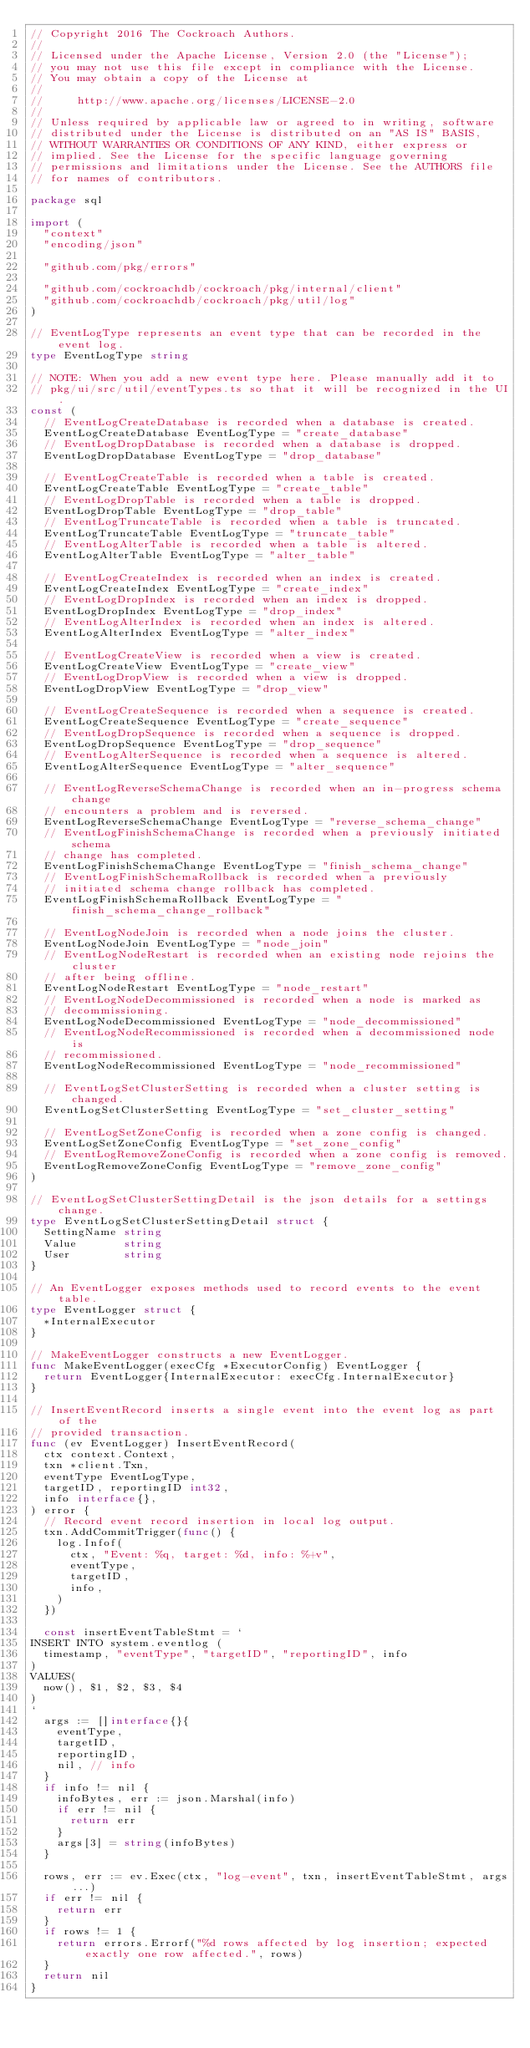Convert code to text. <code><loc_0><loc_0><loc_500><loc_500><_Go_>// Copyright 2016 The Cockroach Authors.
//
// Licensed under the Apache License, Version 2.0 (the "License");
// you may not use this file except in compliance with the License.
// You may obtain a copy of the License at
//
//     http://www.apache.org/licenses/LICENSE-2.0
//
// Unless required by applicable law or agreed to in writing, software
// distributed under the License is distributed on an "AS IS" BASIS,
// WITHOUT WARRANTIES OR CONDITIONS OF ANY KIND, either express or
// implied. See the License for the specific language governing
// permissions and limitations under the License. See the AUTHORS file
// for names of contributors.

package sql

import (
	"context"
	"encoding/json"

	"github.com/pkg/errors"

	"github.com/cockroachdb/cockroach/pkg/internal/client"
	"github.com/cockroachdb/cockroach/pkg/util/log"
)

// EventLogType represents an event type that can be recorded in the event log.
type EventLogType string

// NOTE: When you add a new event type here. Please manually add it to
// pkg/ui/src/util/eventTypes.ts so that it will be recognized in the UI.
const (
	// EventLogCreateDatabase is recorded when a database is created.
	EventLogCreateDatabase EventLogType = "create_database"
	// EventLogDropDatabase is recorded when a database is dropped.
	EventLogDropDatabase EventLogType = "drop_database"

	// EventLogCreateTable is recorded when a table is created.
	EventLogCreateTable EventLogType = "create_table"
	// EventLogDropTable is recorded when a table is dropped.
	EventLogDropTable EventLogType = "drop_table"
	// EventLogTruncateTable is recorded when a table is truncated.
	EventLogTruncateTable EventLogType = "truncate_table"
	// EventLogAlterTable is recorded when a table is altered.
	EventLogAlterTable EventLogType = "alter_table"

	// EventLogCreateIndex is recorded when an index is created.
	EventLogCreateIndex EventLogType = "create_index"
	// EventLogDropIndex is recorded when an index is dropped.
	EventLogDropIndex EventLogType = "drop_index"
	// EventLogAlterIndex is recorded when an index is altered.
	EventLogAlterIndex EventLogType = "alter_index"

	// EventLogCreateView is recorded when a view is created.
	EventLogCreateView EventLogType = "create_view"
	// EventLogDropView is recorded when a view is dropped.
	EventLogDropView EventLogType = "drop_view"

	// EventLogCreateSequence is recorded when a sequence is created.
	EventLogCreateSequence EventLogType = "create_sequence"
	// EventLogDropSequence is recorded when a sequence is dropped.
	EventLogDropSequence EventLogType = "drop_sequence"
	// EventLogAlterSequence is recorded when a sequence is altered.
	EventLogAlterSequence EventLogType = "alter_sequence"

	// EventLogReverseSchemaChange is recorded when an in-progress schema change
	// encounters a problem and is reversed.
	EventLogReverseSchemaChange EventLogType = "reverse_schema_change"
	// EventLogFinishSchemaChange is recorded when a previously initiated schema
	// change has completed.
	EventLogFinishSchemaChange EventLogType = "finish_schema_change"
	// EventLogFinishSchemaRollback is recorded when a previously
	// initiated schema change rollback has completed.
	EventLogFinishSchemaRollback EventLogType = "finish_schema_change_rollback"

	// EventLogNodeJoin is recorded when a node joins the cluster.
	EventLogNodeJoin EventLogType = "node_join"
	// EventLogNodeRestart is recorded when an existing node rejoins the cluster
	// after being offline.
	EventLogNodeRestart EventLogType = "node_restart"
	// EventLogNodeDecommissioned is recorded when a node is marked as
	// decommissioning.
	EventLogNodeDecommissioned EventLogType = "node_decommissioned"
	// EventLogNodeRecommissioned is recorded when a decommissioned node is
	// recommissioned.
	EventLogNodeRecommissioned EventLogType = "node_recommissioned"

	// EventLogSetClusterSetting is recorded when a cluster setting is changed.
	EventLogSetClusterSetting EventLogType = "set_cluster_setting"

	// EventLogSetZoneConfig is recorded when a zone config is changed.
	EventLogSetZoneConfig EventLogType = "set_zone_config"
	// EventLogRemoveZoneConfig is recorded when a zone config is removed.
	EventLogRemoveZoneConfig EventLogType = "remove_zone_config"
)

// EventLogSetClusterSettingDetail is the json details for a settings change.
type EventLogSetClusterSettingDetail struct {
	SettingName string
	Value       string
	User        string
}

// An EventLogger exposes methods used to record events to the event table.
type EventLogger struct {
	*InternalExecutor
}

// MakeEventLogger constructs a new EventLogger.
func MakeEventLogger(execCfg *ExecutorConfig) EventLogger {
	return EventLogger{InternalExecutor: execCfg.InternalExecutor}
}

// InsertEventRecord inserts a single event into the event log as part of the
// provided transaction.
func (ev EventLogger) InsertEventRecord(
	ctx context.Context,
	txn *client.Txn,
	eventType EventLogType,
	targetID, reportingID int32,
	info interface{},
) error {
	// Record event record insertion in local log output.
	txn.AddCommitTrigger(func() {
		log.Infof(
			ctx, "Event: %q, target: %d, info: %+v",
			eventType,
			targetID,
			info,
		)
	})

	const insertEventTableStmt = `
INSERT INTO system.eventlog (
  timestamp, "eventType", "targetID", "reportingID", info
)
VALUES(
  now(), $1, $2, $3, $4
)
`
	args := []interface{}{
		eventType,
		targetID,
		reportingID,
		nil, // info
	}
	if info != nil {
		infoBytes, err := json.Marshal(info)
		if err != nil {
			return err
		}
		args[3] = string(infoBytes)
	}

	rows, err := ev.Exec(ctx, "log-event", txn, insertEventTableStmt, args...)
	if err != nil {
		return err
	}
	if rows != 1 {
		return errors.Errorf("%d rows affected by log insertion; expected exactly one row affected.", rows)
	}
	return nil
}
</code> 